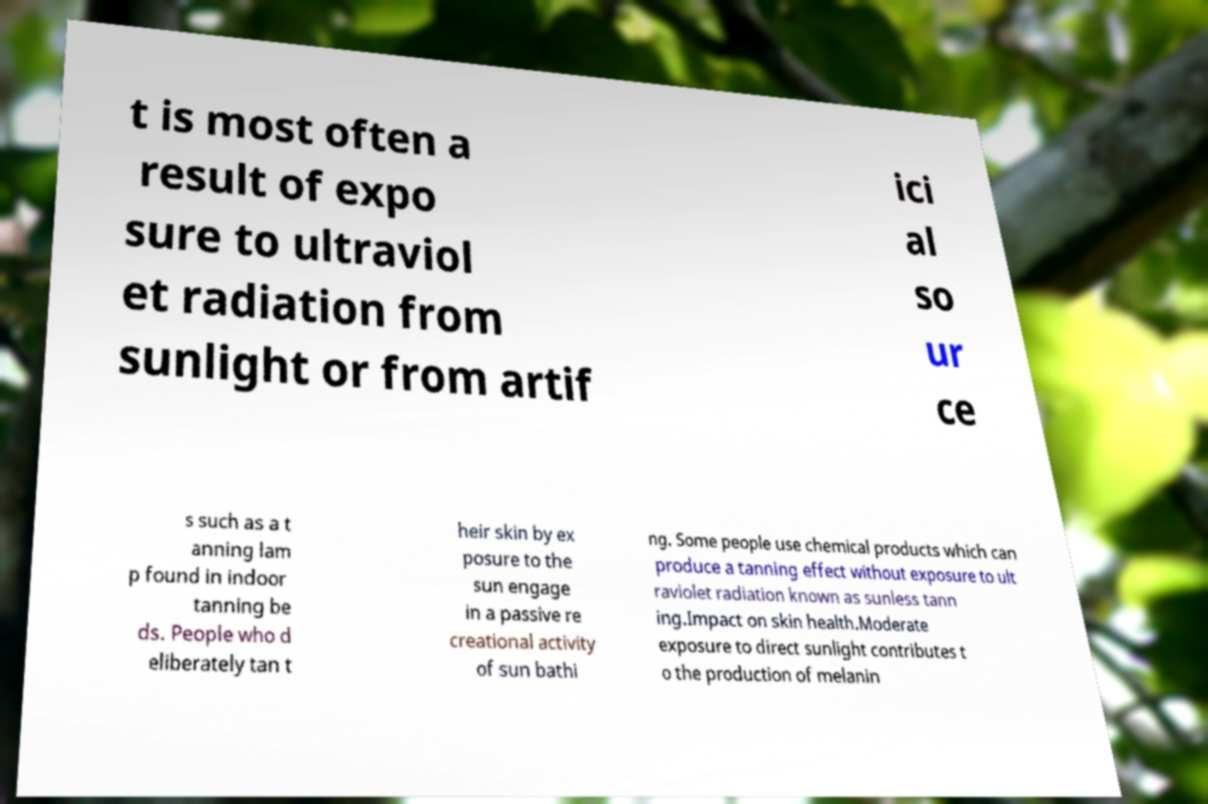Can you read and provide the text displayed in the image?This photo seems to have some interesting text. Can you extract and type it out for me? t is most often a result of expo sure to ultraviol et radiation from sunlight or from artif ici al so ur ce s such as a t anning lam p found in indoor tanning be ds. People who d eliberately tan t heir skin by ex posure to the sun engage in a passive re creational activity of sun bathi ng. Some people use chemical products which can produce a tanning effect without exposure to ult raviolet radiation known as sunless tann ing.Impact on skin health.Moderate exposure to direct sunlight contributes t o the production of melanin 